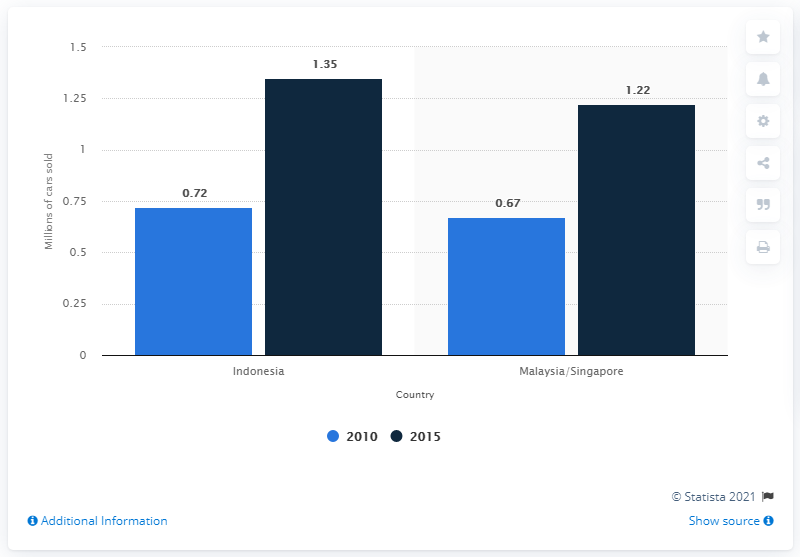Point out several critical features in this image. In 2015, the difference between the highest and lowest number of cards sold was approximately 0.13 million. In 2010, the number of cards sold was approximately 0.72 billion. 